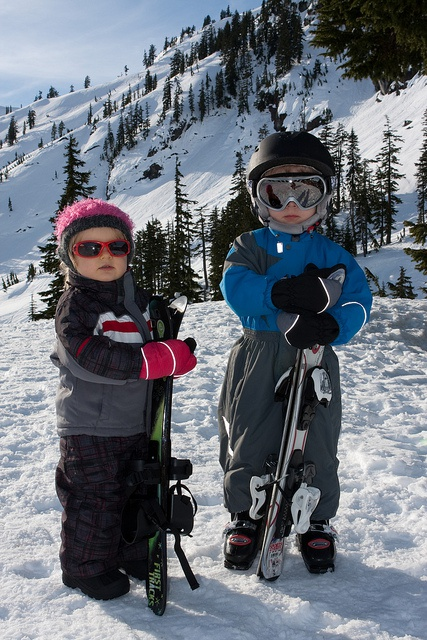Describe the objects in this image and their specific colors. I can see people in lavender, black, gray, and darkblue tones, people in lavender, black, and gray tones, skis in lavender, black, gray, lightgray, and darkgray tones, and skis in lavender, black, gray, and darkgray tones in this image. 